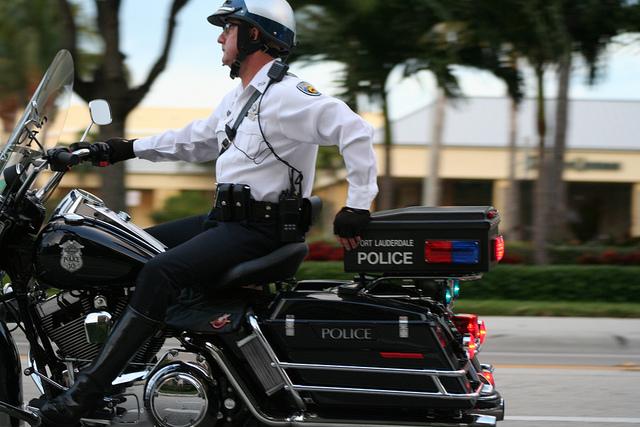Can this man arrest someone?
Short answer required. Yes. What is this man's occupation?
Short answer required. Police officer. What kind of shoes is this man wearing?
Give a very brief answer. Boots. 